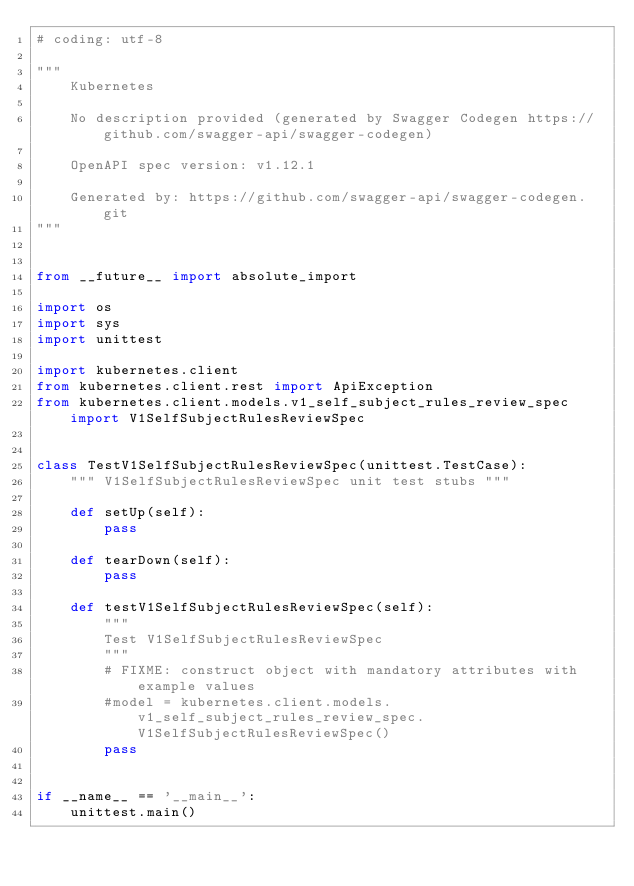<code> <loc_0><loc_0><loc_500><loc_500><_Python_># coding: utf-8

"""
    Kubernetes

    No description provided (generated by Swagger Codegen https://github.com/swagger-api/swagger-codegen)

    OpenAPI spec version: v1.12.1
    
    Generated by: https://github.com/swagger-api/swagger-codegen.git
"""


from __future__ import absolute_import

import os
import sys
import unittest

import kubernetes.client
from kubernetes.client.rest import ApiException
from kubernetes.client.models.v1_self_subject_rules_review_spec import V1SelfSubjectRulesReviewSpec


class TestV1SelfSubjectRulesReviewSpec(unittest.TestCase):
    """ V1SelfSubjectRulesReviewSpec unit test stubs """

    def setUp(self):
        pass

    def tearDown(self):
        pass

    def testV1SelfSubjectRulesReviewSpec(self):
        """
        Test V1SelfSubjectRulesReviewSpec
        """
        # FIXME: construct object with mandatory attributes with example values
        #model = kubernetes.client.models.v1_self_subject_rules_review_spec.V1SelfSubjectRulesReviewSpec()
        pass


if __name__ == '__main__':
    unittest.main()
</code> 